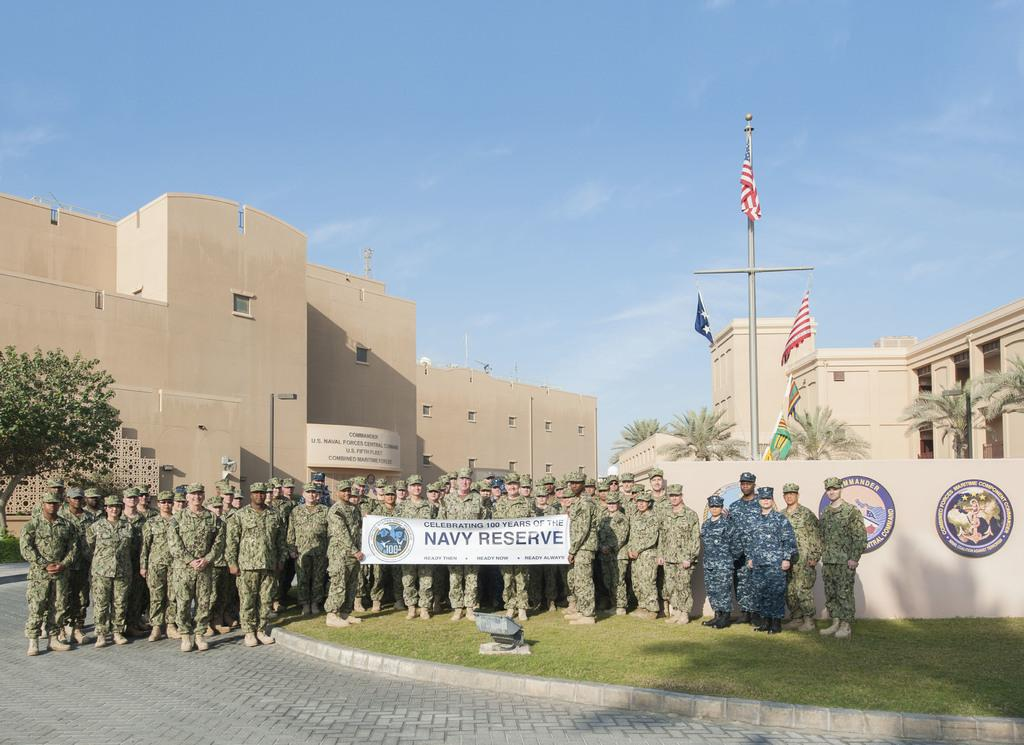How many people are in the group visible in the image? There is a group of people in the image, but the exact number cannot be determined from the provided facts. What are the people in the group holding? The people in the group are holding a banner. What type of terrain is visible in the image? There is grass in the image. What can be seen in the background of the image? Buildings, trees, a pole, flags, boards, and the sky are visible in the background of the image. What type of shame is depicted on the boards in the background of the image? There is no mention of shame or any type of shame in the provided facts. 